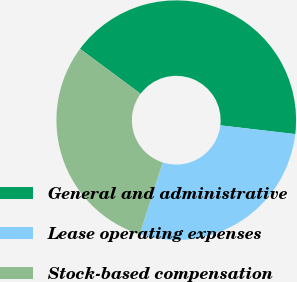Convert chart to OTSL. <chart><loc_0><loc_0><loc_500><loc_500><pie_chart><fcel>General and administrative<fcel>Lease operating expenses<fcel>Stock-based compensation<nl><fcel>41.7%<fcel>28.09%<fcel>30.21%<nl></chart> 